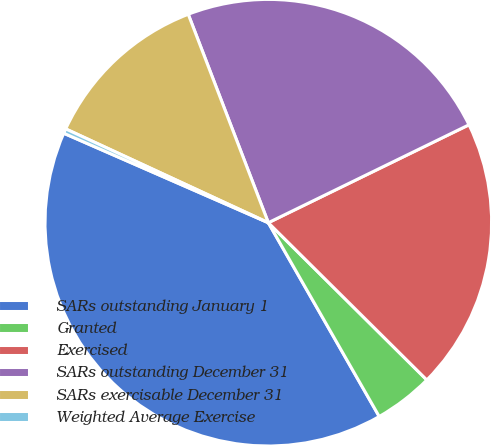Convert chart to OTSL. <chart><loc_0><loc_0><loc_500><loc_500><pie_chart><fcel>SARs outstanding January 1<fcel>Granted<fcel>Exercised<fcel>SARs outstanding December 31<fcel>SARs exercisable December 31<fcel>Weighted Average Exercise<nl><fcel>39.83%<fcel>4.29%<fcel>19.66%<fcel>23.61%<fcel>12.26%<fcel>0.34%<nl></chart> 